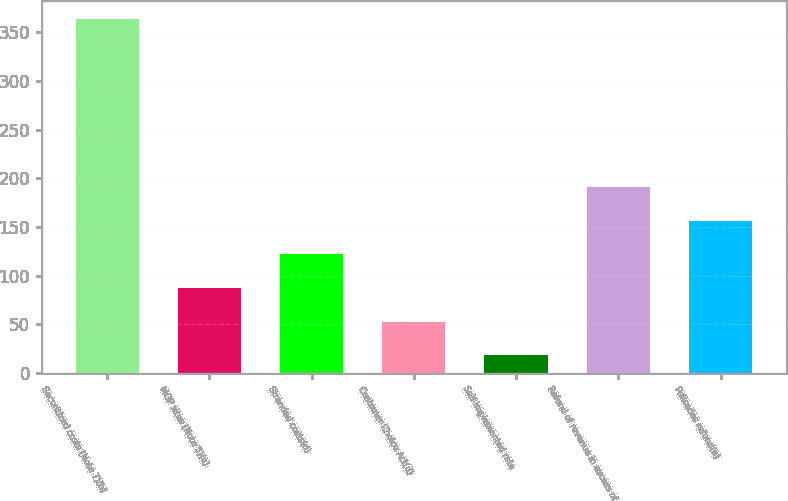<chart> <loc_0><loc_0><loc_500><loc_500><bar_chart><fcel>Securitized costs (Note 7)(b)<fcel>MGP sites (Note 5)(a)<fcel>Stranded costs(d)<fcel>Customer Choice Act(d)<fcel>Self-implemented rate<fcel>Refund of revenue in excess of<fcel>Palisades refund(n)<nl><fcel>364<fcel>87.2<fcel>121.8<fcel>52.6<fcel>18<fcel>191<fcel>156.4<nl></chart> 